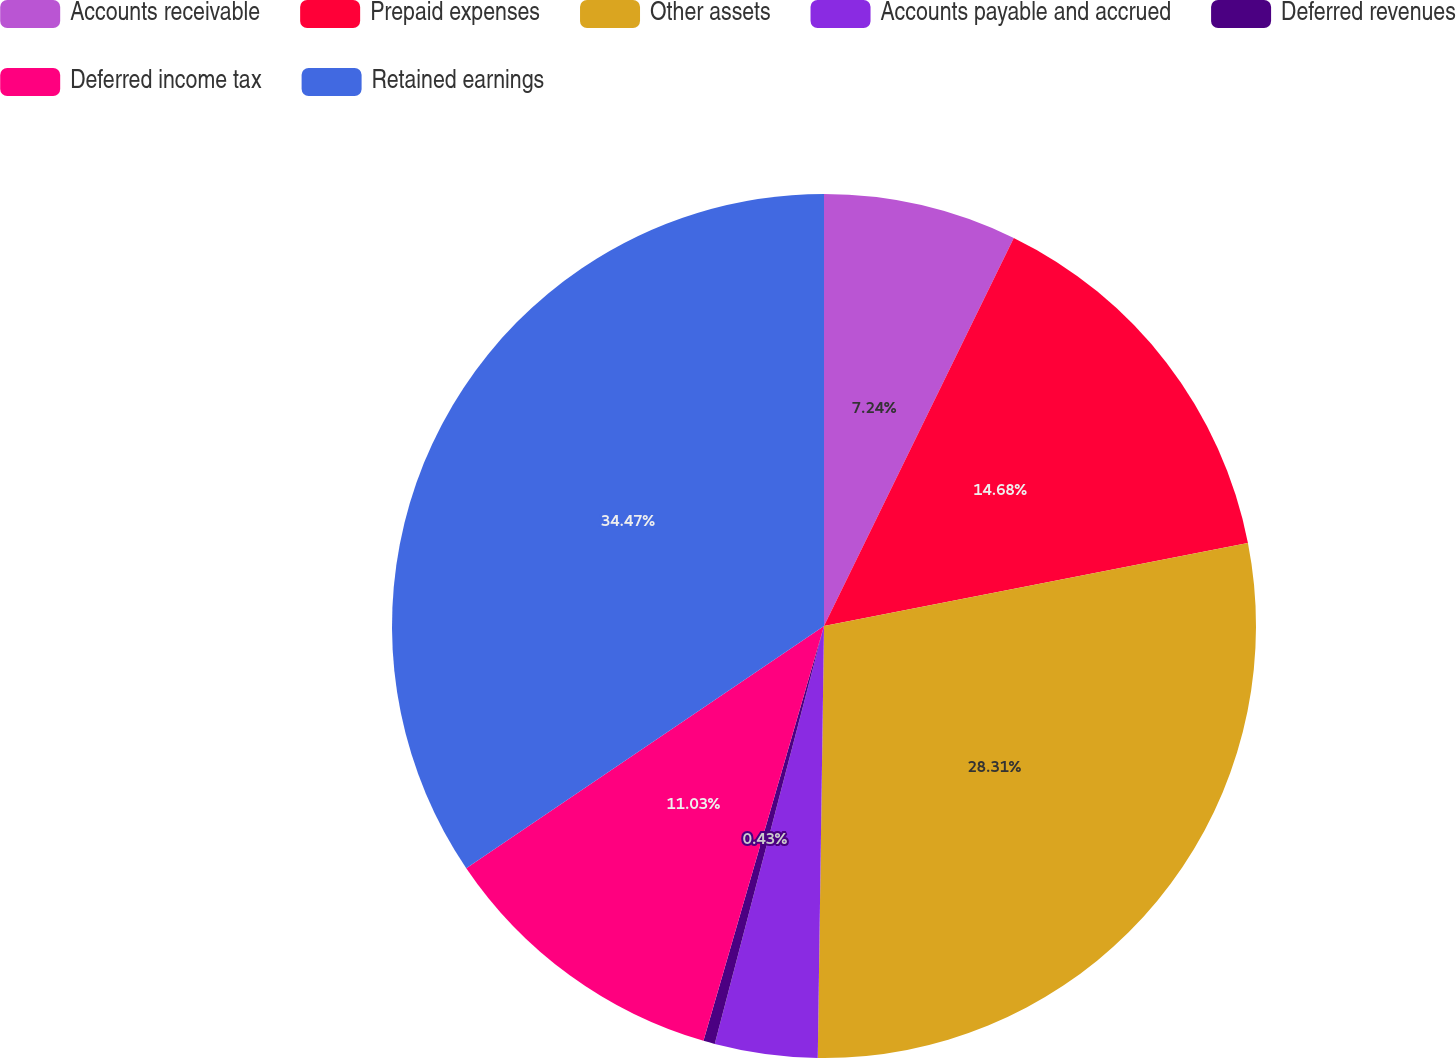Convert chart to OTSL. <chart><loc_0><loc_0><loc_500><loc_500><pie_chart><fcel>Accounts receivable<fcel>Prepaid expenses<fcel>Other assets<fcel>Accounts payable and accrued<fcel>Deferred revenues<fcel>Deferred income tax<fcel>Retained earnings<nl><fcel>7.24%<fcel>14.68%<fcel>28.31%<fcel>3.84%<fcel>0.43%<fcel>11.03%<fcel>34.47%<nl></chart> 